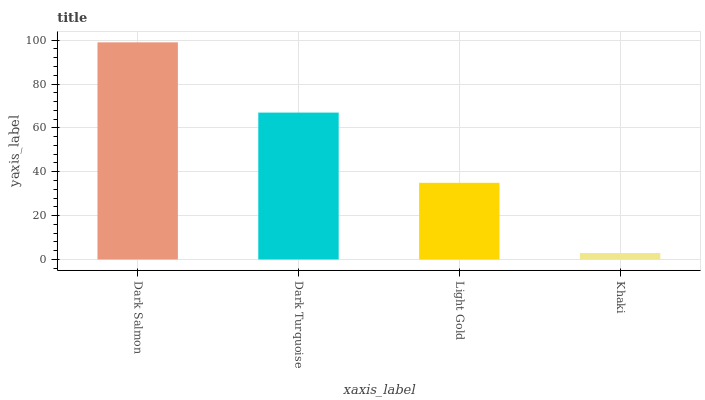Is Khaki the minimum?
Answer yes or no. Yes. Is Dark Salmon the maximum?
Answer yes or no. Yes. Is Dark Turquoise the minimum?
Answer yes or no. No. Is Dark Turquoise the maximum?
Answer yes or no. No. Is Dark Salmon greater than Dark Turquoise?
Answer yes or no. Yes. Is Dark Turquoise less than Dark Salmon?
Answer yes or no. Yes. Is Dark Turquoise greater than Dark Salmon?
Answer yes or no. No. Is Dark Salmon less than Dark Turquoise?
Answer yes or no. No. Is Dark Turquoise the high median?
Answer yes or no. Yes. Is Light Gold the low median?
Answer yes or no. Yes. Is Light Gold the high median?
Answer yes or no. No. Is Dark Turquoise the low median?
Answer yes or no. No. 